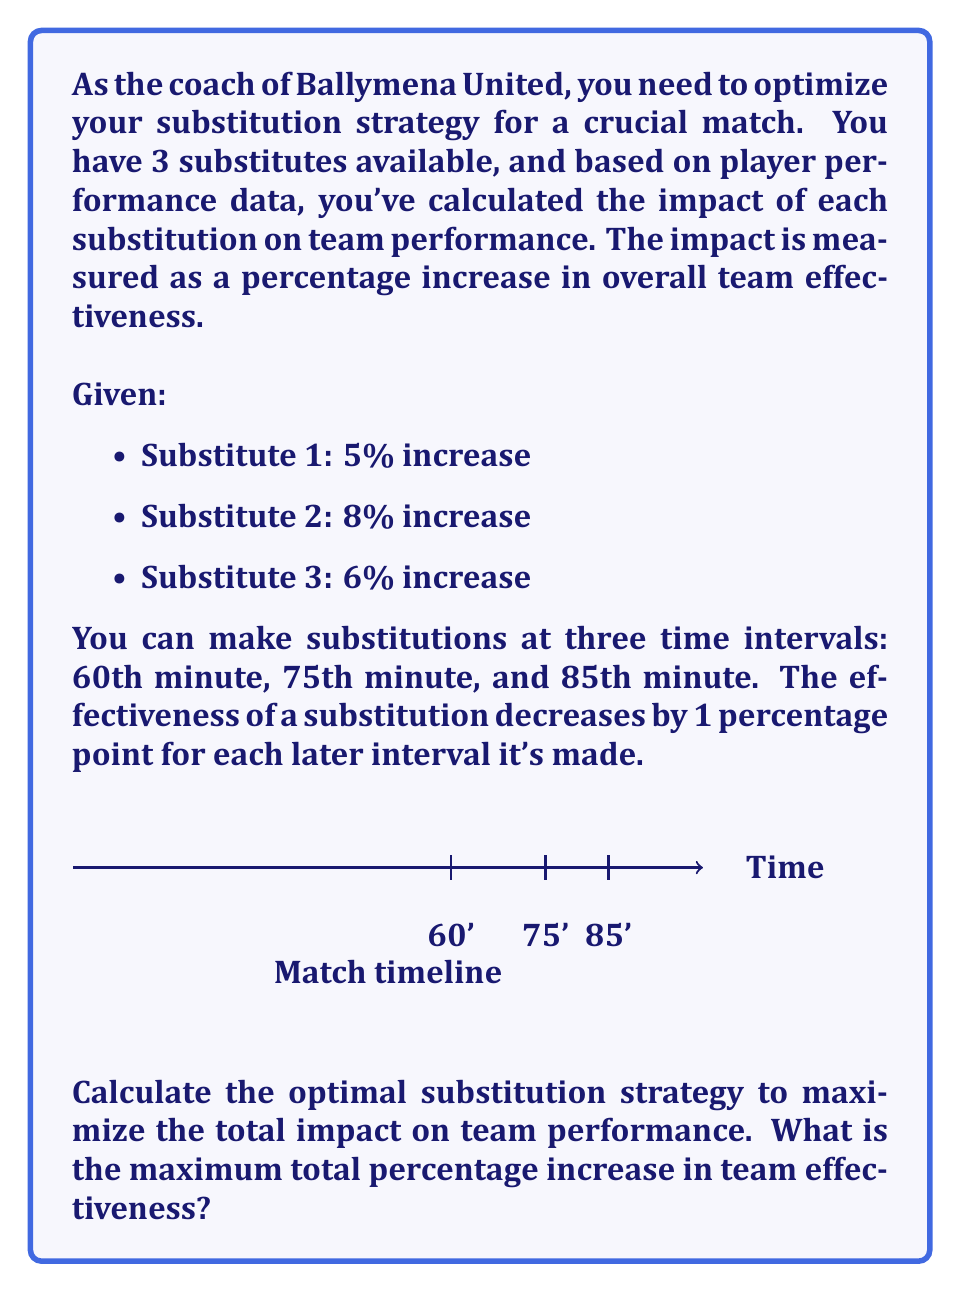Solve this math problem. Let's approach this step-by-step:

1) First, we need to understand how the effectiveness changes over time:
   - At 60 minutes: No decrease
   - At 75 minutes: 1 percentage point decrease
   - At 85 minutes: 2 percentage points decrease

2) Now, let's calculate the effectiveness of each substitute at each time interval:

   Substitute 1 (5%):
   - 60 minutes: 5%
   - 75 minutes: 4%
   - 85 minutes: 3%

   Substitute 2 (8%):
   - 60 minutes: 8%
   - 75 minutes: 7%
   - 85 minutes: 6%

   Substitute 3 (6%):
   - 60 minutes: 6%
   - 75 minutes: 5%
   - 85 minutes: 4%

3) To maximize the total impact, we should use the most effective substitutes earlier:
   - Use Substitute 2 (highest impact) at 60 minutes: 8%
   - Use Substitute 3 (second highest impact) at 75 minutes: 5%
   - Use Substitute 1 (lowest impact) at 85 minutes: 3%

4) Calculate the total impact:
   $$ \text{Total Impact} = 8\% + 5\% + 3\% = 16\% $$

Therefore, the optimal substitution strategy is to use Substitute 2 at 60 minutes, Substitute 3 at 75 minutes, and Substitute 1 at 85 minutes.
Answer: 16% 